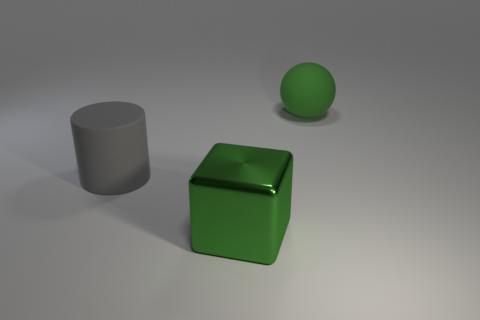What is the size of the cube that is the same color as the ball?
Provide a succinct answer. Large. There is a green block; are there any matte things to the left of it?
Offer a very short reply. Yes. How many other objects are the same shape as the gray rubber thing?
Give a very brief answer. 0. There is a shiny block that is the same size as the gray matte thing; what color is it?
Offer a very short reply. Green. Are there fewer objects to the left of the gray cylinder than large blocks that are on the right side of the green shiny thing?
Make the answer very short. No. There is a big matte object in front of the green object behind the large gray matte object; what number of big spheres are behind it?
Your answer should be very brief. 1. Is there anything else that has the same size as the green ball?
Your answer should be very brief. Yes. Are there fewer gray rubber things to the right of the large block than big gray objects?
Ensure brevity in your answer.  Yes. Do the gray rubber object and the green rubber thing have the same shape?
Your answer should be compact. No. How many things are the same color as the large cube?
Make the answer very short. 1. 